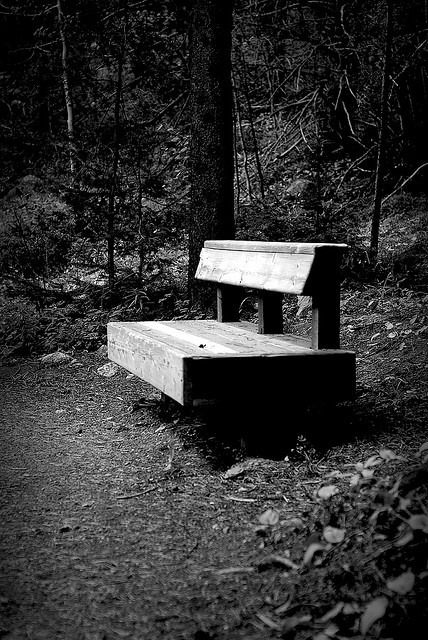Describe the objects in this image and their specific colors. I can see a bench in black, lightgray, darkgray, and gray tones in this image. 